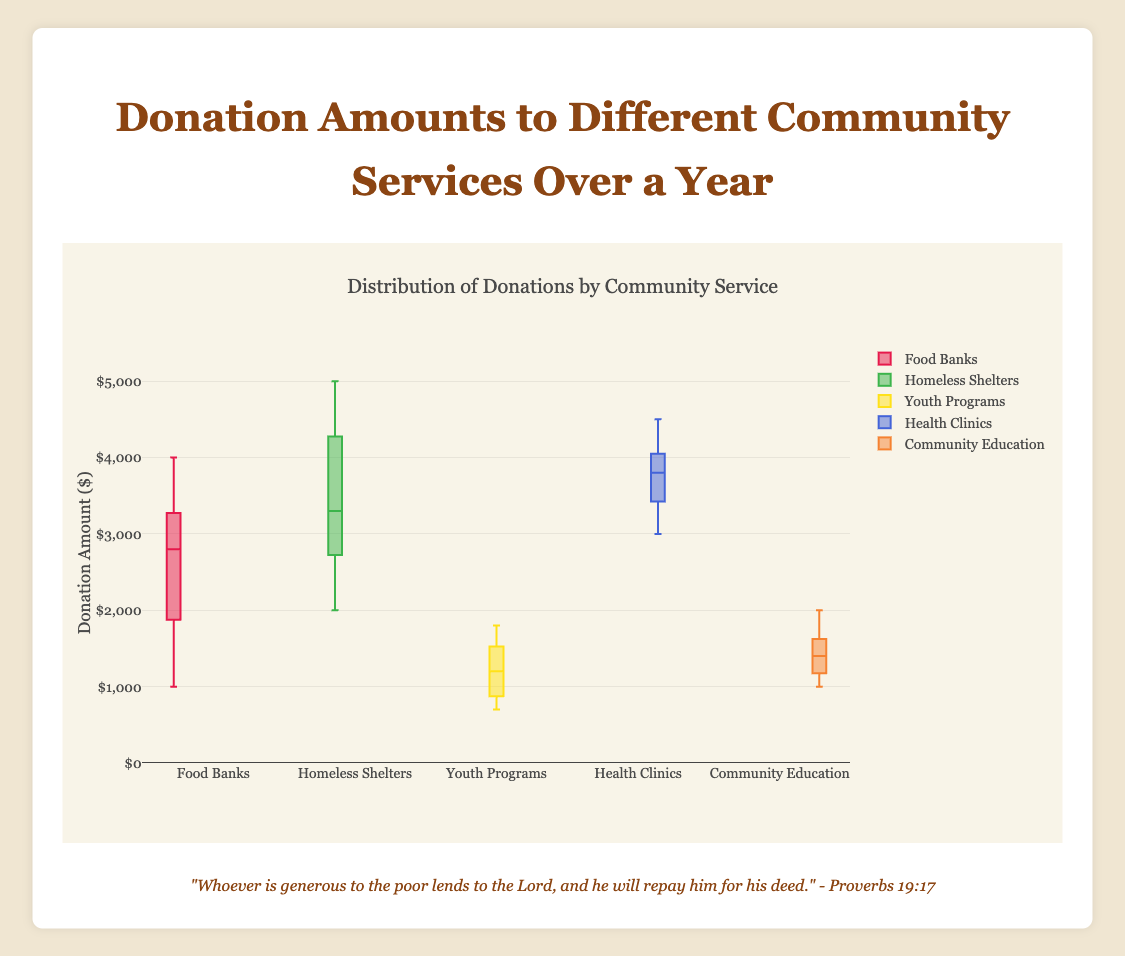What is the title of the figure? The title of the figure is typically found at the top of the chart. It provides a brief description of what the figure represents. In this case, the title is visible at the top center of the figure.
Answer: Donation Amounts to Different Community Services Over a Year How many community services are represented in the figure? By observing the number of different box plots, each labeled with the name of a community service, it’s clear how many distinct categories are present.
Answer: 5 Which community service received the highest maximum donation? Inspecting the upper whisker or outlier of each box plot will reveal the maximum donation for each service. The one reaching the highest value indicates the highest maximum donation received.
Answer: Homeless Shelters What's the median donation amount for Youth Programs? The median is represented by the line inside the box for Youth Programs. By examining this line, we can identify the median value.
Answer: 1200 What is the interquartile range (IQR) of donations for Health Clinics? The IQR can be found by calculating the difference between the upper quartile (Q3) and the lower quartile (Q1) of Health Clinics. These are the top and bottom edges of the box, respectively.
Answer: 4000 - 3500 = 500 Which service has the lowest median donation amount? By comparing the positions of the median lines within each box plot, it’s possible to identify the service with the lowest median donation amount.
Answer: Youth Programs How do the maximum donations for Food Banks and Homeless Shelters compare? To compare them, look at the upper whiskers or the highest points of the boxes for both Food Banks and Homeless Shelters. This helps identify which has a higher maximum donation.
Answer: Homeless Shelters have a higher maximum donation than Food Banks Which community service shows the most variability in donation amounts within its interquartile range? Variability within the IQR is indicated by the height of each box. A taller box indicates more variability. By comparing the height of the boxes, we can determine which service has the most variability.
Answer: Food Banks What can be inferred about the consistency of donations to Community Education? Consistency can be inferred by examining the spread and density of the data points within the box plot for Community Education. A smaller IQR and fewer outliers suggest more consistent donations.
Answer: Donations to Community Education are relatively consistent 